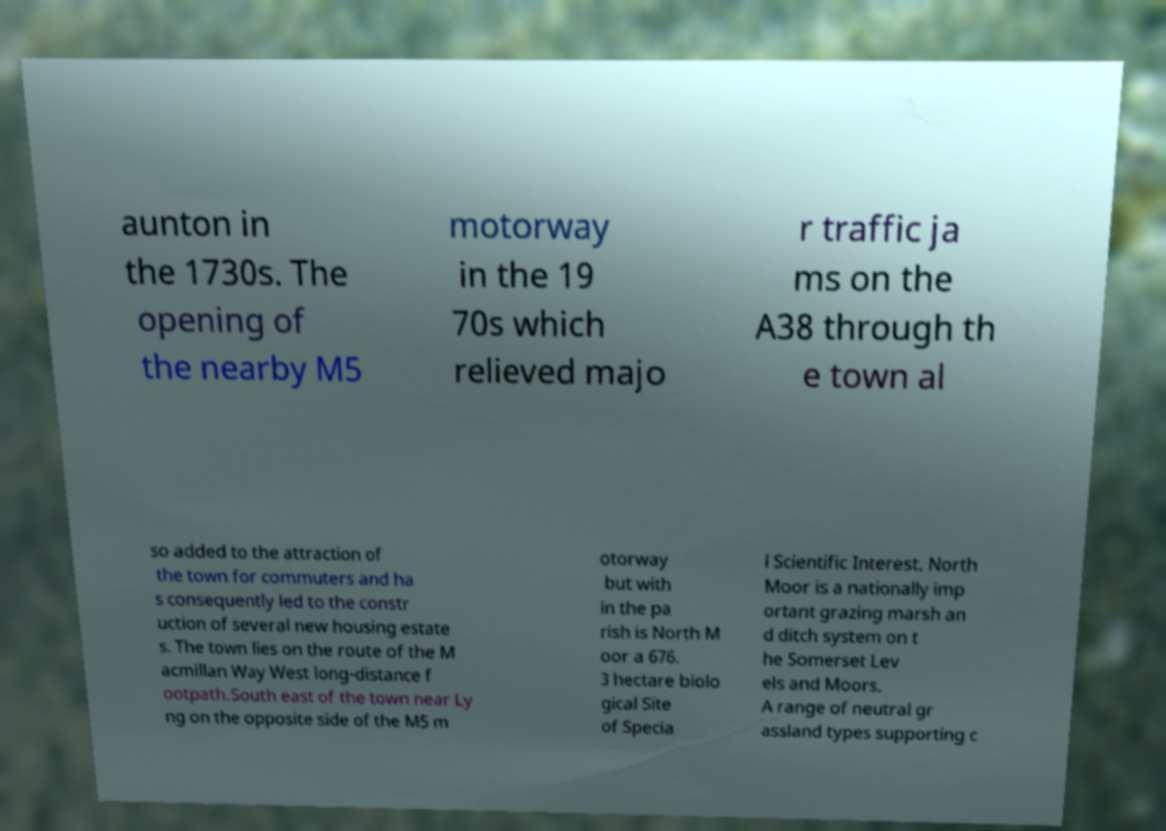Can you read and provide the text displayed in the image?This photo seems to have some interesting text. Can you extract and type it out for me? aunton in the 1730s. The opening of the nearby M5 motorway in the 19 70s which relieved majo r traffic ja ms on the A38 through th e town al so added to the attraction of the town for commuters and ha s consequently led to the constr uction of several new housing estate s. The town lies on the route of the M acmillan Way West long-distance f ootpath.South east of the town near Ly ng on the opposite side of the M5 m otorway but with in the pa rish is North M oor a 676. 3 hectare biolo gical Site of Specia l Scientific Interest. North Moor is a nationally imp ortant grazing marsh an d ditch system on t he Somerset Lev els and Moors. A range of neutral gr assland types supporting c 